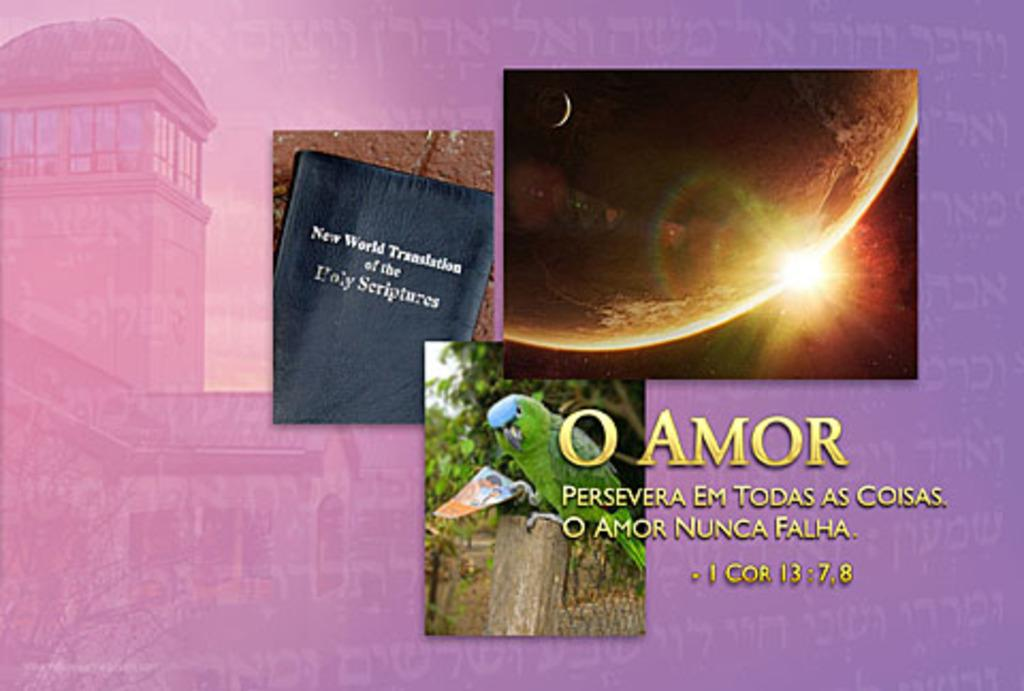<image>
Describe the image concisely. Spiritual type message from the new world translation mentioning a bible verse 1 Corinthians 13: 7,8. 